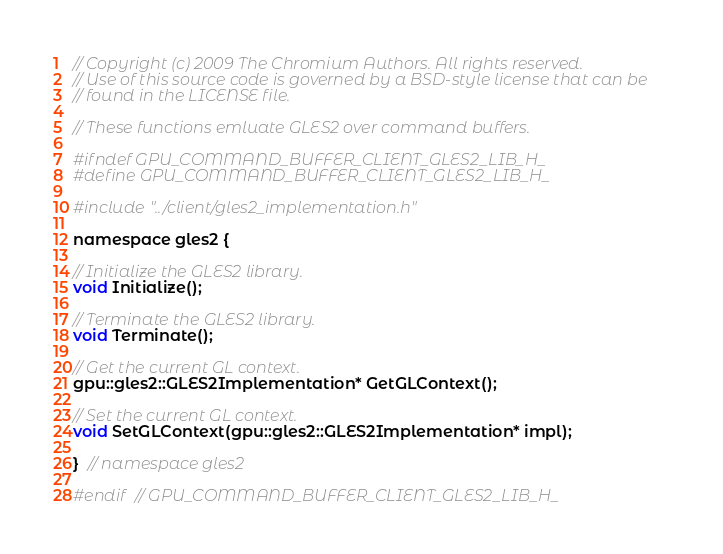Convert code to text. <code><loc_0><loc_0><loc_500><loc_500><_C_>// Copyright (c) 2009 The Chromium Authors. All rights reserved.
// Use of this source code is governed by a BSD-style license that can be
// found in the LICENSE file.

// These functions emluate GLES2 over command buffers.

#ifndef GPU_COMMAND_BUFFER_CLIENT_GLES2_LIB_H_
#define GPU_COMMAND_BUFFER_CLIENT_GLES2_LIB_H_

#include "../client/gles2_implementation.h"

namespace gles2 {

// Initialize the GLES2 library.
void Initialize();

// Terminate the GLES2 library.
void Terminate();

// Get the current GL context.
gpu::gles2::GLES2Implementation* GetGLContext();

// Set the current GL context.
void SetGLContext(gpu::gles2::GLES2Implementation* impl);

}  // namespace gles2

#endif  // GPU_COMMAND_BUFFER_CLIENT_GLES2_LIB_H_
</code> 